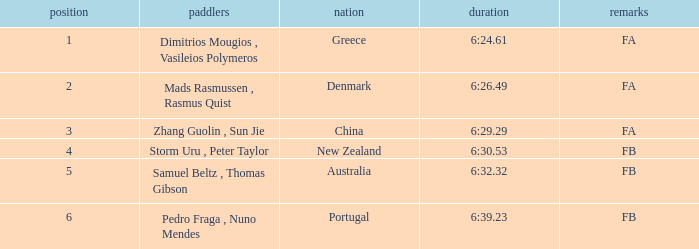What country has a rank smaller than 6, a time of 6:32.32 and notes of FB? Australia. 